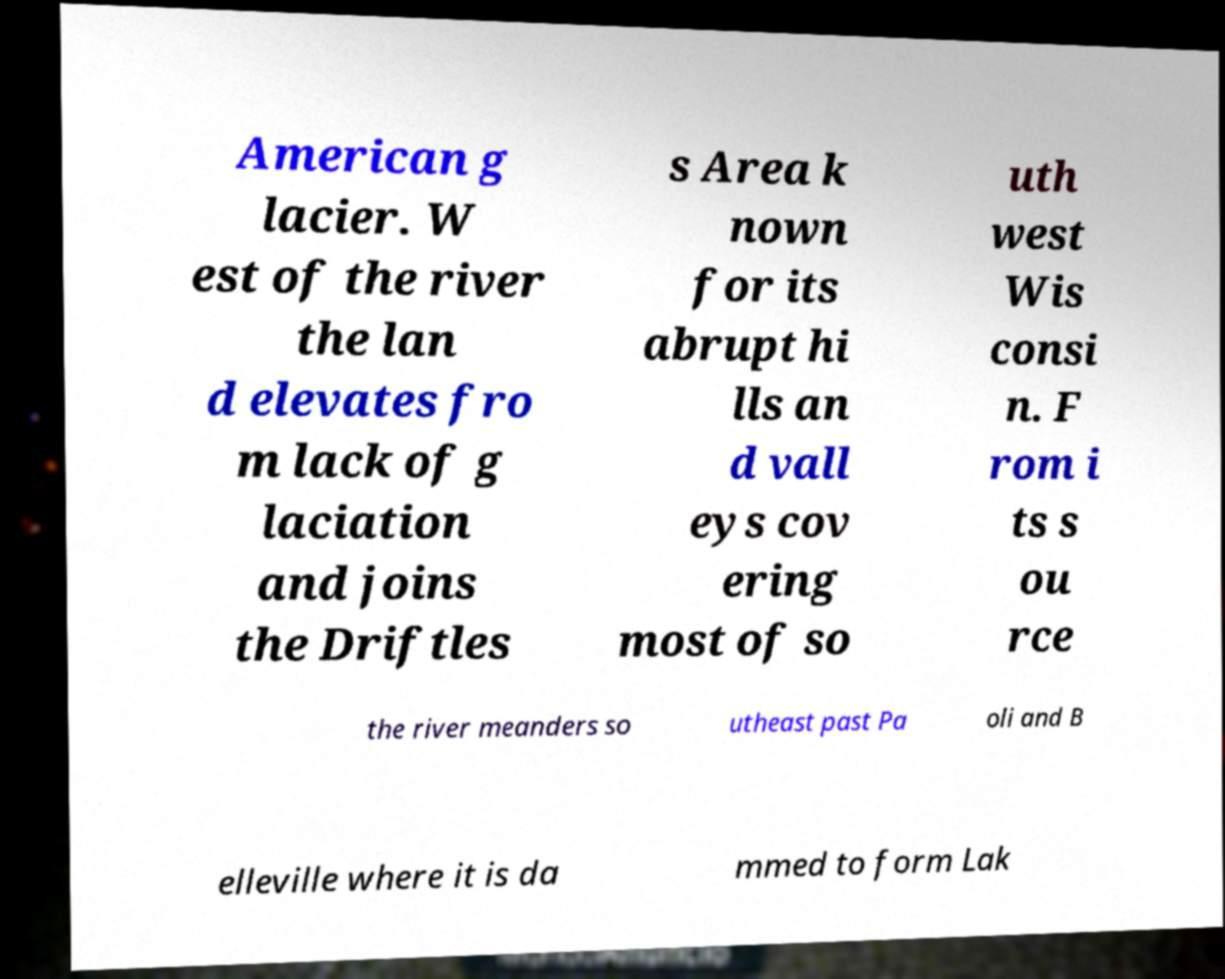Can you accurately transcribe the text from the provided image for me? American g lacier. W est of the river the lan d elevates fro m lack of g laciation and joins the Driftles s Area k nown for its abrupt hi lls an d vall eys cov ering most of so uth west Wis consi n. F rom i ts s ou rce the river meanders so utheast past Pa oli and B elleville where it is da mmed to form Lak 